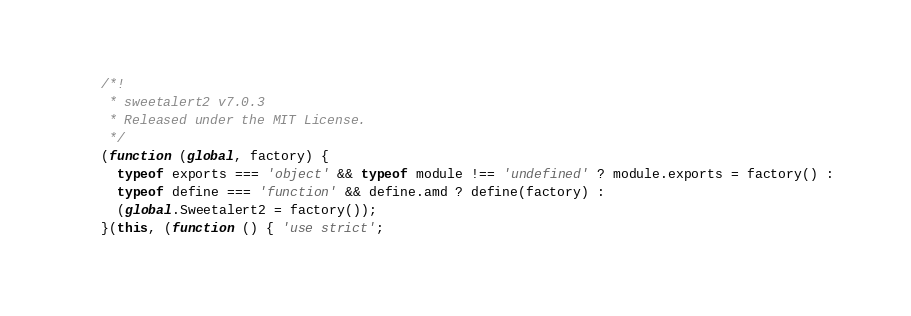Convert code to text. <code><loc_0><loc_0><loc_500><loc_500><_JavaScript_>/*!
 * sweetalert2 v7.0.3
 * Released under the MIT License.
 */
(function (global, factory) {
  typeof exports === 'object' && typeof module !== 'undefined' ? module.exports = factory() :
  typeof define === 'function' && define.amd ? define(factory) :
  (global.Sweetalert2 = factory());
}(this, (function () { 'use strict';
</code> 